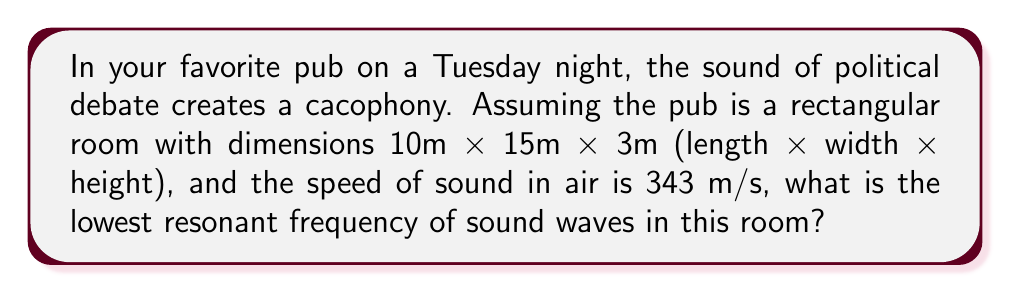Teach me how to tackle this problem. To solve this problem, we'll use the wave equation for a rectangular room:

$$f_{nx,ny,nz} = \frac{c}{2} \sqrt{\left(\frac{n_x}{L_x}\right)^2 + \left(\frac{n_y}{L_y}\right)^2 + \left(\frac{n_z}{L_z}\right)^2}$$

Where:
- $f$ is the resonant frequency
- $c$ is the speed of sound
- $L_x$, $L_y$, and $L_z$ are the room dimensions
- $n_x$, $n_y$, and $n_z$ are non-negative integers

The lowest resonant frequency occurs when $n_x = 1$, $n_y = 0$, and $n_z = 0$.

Step 1: Substitute the values into the equation:
$$f_{1,0,0} = \frac{343}{2} \sqrt{\left(\frac{1}{10}\right)^2 + \left(\frac{0}{15}\right)^2 + \left(\frac{0}{3}\right)^2}$$

Step 2: Simplify:
$$f_{1,0,0} = \frac{343}{2} \sqrt{\frac{1}{100}}$$

Step 3: Calculate:
$$f_{1,0,0} = \frac{343}{2} \cdot \frac{1}{10} = 17.15 \text{ Hz}$$

Therefore, the lowest resonant frequency in the pub is approximately 17.15 Hz.
Answer: 17.15 Hz 